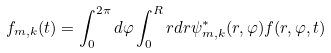<formula> <loc_0><loc_0><loc_500><loc_500>f _ { m , k } ( t ) = \int _ { 0 } ^ { 2 \pi } d \varphi \int _ { 0 } ^ { R } r d r \psi _ { m , k } ^ { * } ( r , \varphi ) f ( r , \varphi , t )</formula> 